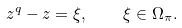Convert formula to latex. <formula><loc_0><loc_0><loc_500><loc_500>z ^ { q } - z = \xi , \quad \xi \in \Omega _ { \pi } .</formula> 